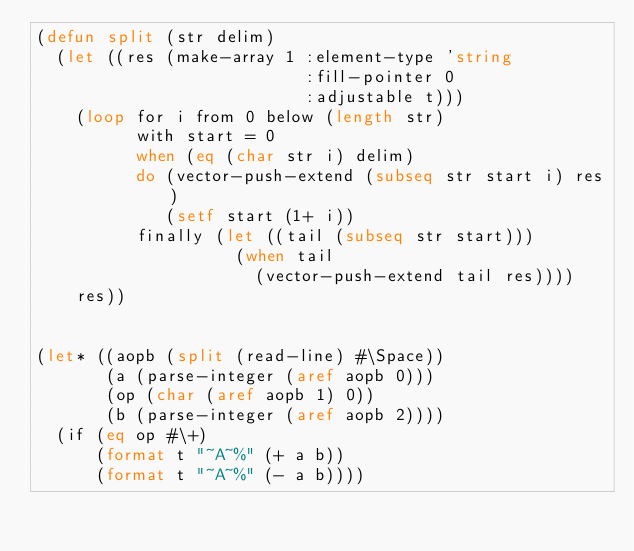Convert code to text. <code><loc_0><loc_0><loc_500><loc_500><_Lisp_>(defun split (str delim)
  (let ((res (make-array 1 :element-type 'string
                           :fill-pointer 0
                           :adjustable t)))
    (loop for i from 0 below (length str)
          with start = 0
          when (eq (char str i) delim)
          do (vector-push-extend (subseq str start i) res)
             (setf start (1+ i))
          finally (let ((tail (subseq str start)))
                    (when tail
                      (vector-push-extend tail res))))
    res))


(let* ((aopb (split (read-line) #\Space))
       (a (parse-integer (aref aopb 0)))
       (op (char (aref aopb 1) 0))
       (b (parse-integer (aref aopb 2))))
  (if (eq op #\+)
      (format t "~A~%" (+ a b))
      (format t "~A~%" (- a b))))</code> 